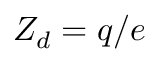Convert formula to latex. <formula><loc_0><loc_0><loc_500><loc_500>Z _ { d } = q / e</formula> 